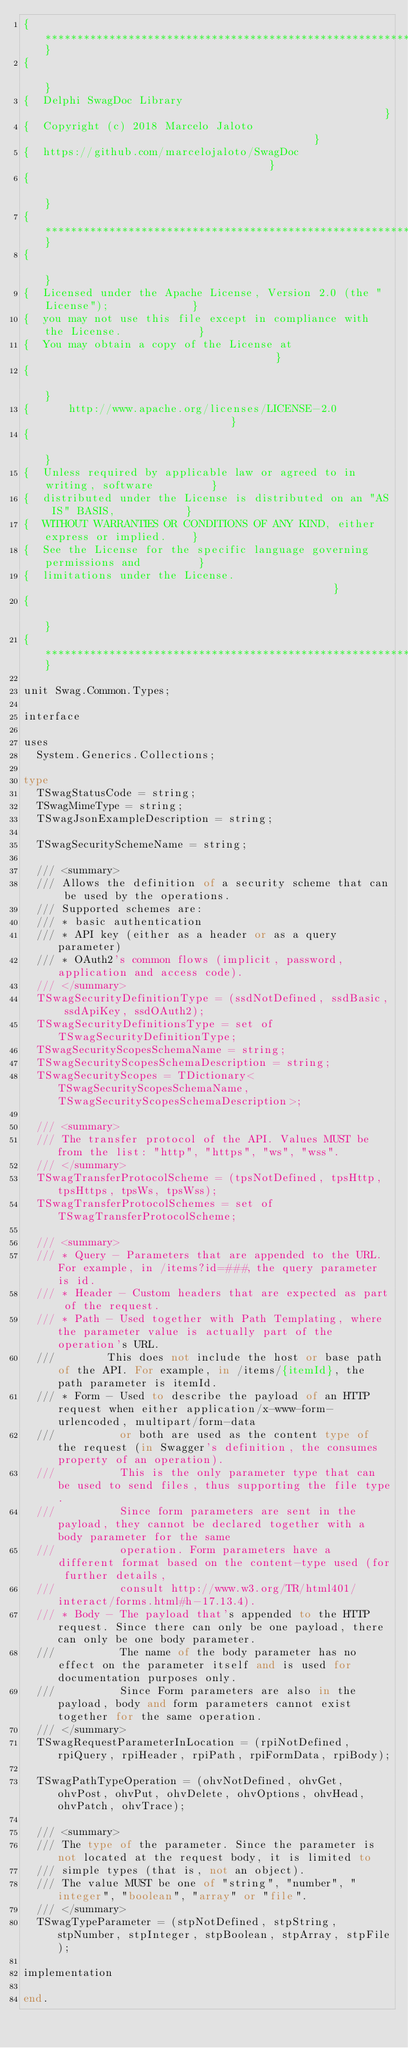<code> <loc_0><loc_0><loc_500><loc_500><_Pascal_>{******************************************************************************}
{                                                                              }
{  Delphi SwagDoc Library                                                      }
{  Copyright (c) 2018 Marcelo Jaloto                                           }
{  https://github.com/marcelojaloto/SwagDoc                                    }
{                                                                              }
{******************************************************************************}
{                                                                              }
{  Licensed under the Apache License, Version 2.0 (the "License");             }
{  you may not use this file except in compliance with the License.            }
{  You may obtain a copy of the License at                                     }
{                                                                              }
{      http://www.apache.org/licenses/LICENSE-2.0                              }
{                                                                              }
{  Unless required by applicable law or agreed to in writing, software         }
{  distributed under the License is distributed on an "AS IS" BASIS,           }
{  WITHOUT WARRANTIES OR CONDITIONS OF ANY KIND, either express or implied.    }
{  See the License for the specific language governing permissions and         }
{  limitations under the License.                                              }
{                                                                              }
{******************************************************************************}

unit Swag.Common.Types;

interface

uses
  System.Generics.Collections;

type
  TSwagStatusCode = string;
  TSwagMimeType = string;
  TSwagJsonExampleDescription = string;

  TSwagSecuritySchemeName = string;

  /// <summary>
  /// Allows the definition of a security scheme that can be used by the operations.
  /// Supported schemes are:
  /// * basic authentication
  /// * API key (either as a header or as a query parameter)
  /// * OAuth2's common flows (implicit, password, application and access code).
  /// </summary>
  TSwagSecurityDefinitionType = (ssdNotDefined, ssdBasic, ssdApiKey, ssdOAuth2);
  TSwagSecurityDefinitionsType = set of TSwagSecurityDefinitionType;
  TSwagSecurityScopesSchemaName = string;
  TSwagSecurityScopesSchemaDescription = string;
  TSwagSecurityScopes = TDictionary<TSwagSecurityScopesSchemaName, TSwagSecurityScopesSchemaDescription>;

  /// <summary>
  /// The transfer protocol of the API. Values MUST be from the list: "http", "https", "ws", "wss".
  /// </summary>
  TSwagTransferProtocolScheme = (tpsNotDefined, tpsHttp, tpsHttps, tpsWs, tpsWss);
  TSwagTransferProtocolSchemes = set of TSwagTransferProtocolScheme;

  /// <summary>
  /// * Query - Parameters that are appended to the URL. For example, in /items?id=###, the query parameter is id.
  /// * Header - Custom headers that are expected as part of the request.
  /// * Path - Used together with Path Templating, where the parameter value is actually part of the operation's URL.
  ///        This does not include the host or base path of the API. For example, in /items/{itemId}, the path parameter is itemId.
  /// * Form - Used to describe the payload of an HTTP request when either application/x-www-form-urlencoded, multipart/form-data
  ///          or both are used as the content type of the request (in Swagger's definition, the consumes property of an operation).
  ///          This is the only parameter type that can be used to send files, thus supporting the file type.
  ///          Since form parameters are sent in the payload, they cannot be declared together with a body parameter for the same
  ///          operation. Form parameters have a different format based on the content-type used (for further details,
  ///          consult http://www.w3.org/TR/html401/interact/forms.html#h-17.13.4).
  /// * Body - The payload that's appended to the HTTP request. Since there can only be one payload, there can only be one body parameter.
  ///          The name of the body parameter has no effect on the parameter itself and is used for documentation purposes only.
  ///          Since Form parameters are also in the payload, body and form parameters cannot exist together for the same operation.
  /// </summary>
  TSwagRequestParameterInLocation = (rpiNotDefined, rpiQuery, rpiHeader, rpiPath, rpiFormData, rpiBody);

  TSwagPathTypeOperation = (ohvNotDefined, ohvGet, ohvPost, ohvPut, ohvDelete, ohvOptions, ohvHead, ohvPatch, ohvTrace);

  /// <summary>
  /// The type of the parameter. Since the parameter is not located at the request body, it is limited to
  /// simple types (that is, not an object).
  /// The value MUST be one of "string", "number", "integer", "boolean", "array" or "file".
  /// </summary>
  TSwagTypeParameter = (stpNotDefined, stpString, stpNumber, stpInteger, stpBoolean, stpArray, stpFile);

implementation

end.
</code> 